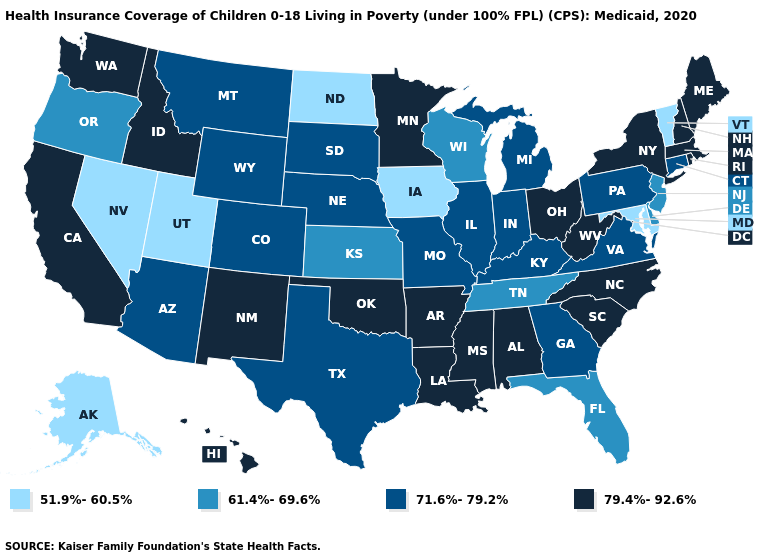What is the highest value in states that border Minnesota?
Keep it brief. 71.6%-79.2%. Does the first symbol in the legend represent the smallest category?
Write a very short answer. Yes. What is the value of Connecticut?
Give a very brief answer. 71.6%-79.2%. Which states have the lowest value in the USA?
Quick response, please. Alaska, Iowa, Maryland, Nevada, North Dakota, Utah, Vermont. What is the highest value in states that border Louisiana?
Give a very brief answer. 79.4%-92.6%. Among the states that border North Carolina , which have the highest value?
Write a very short answer. South Carolina. What is the value of Arkansas?
Short answer required. 79.4%-92.6%. Does the first symbol in the legend represent the smallest category?
Answer briefly. Yes. What is the lowest value in the USA?
Answer briefly. 51.9%-60.5%. Does Louisiana have a lower value than Ohio?
Give a very brief answer. No. What is the value of Vermont?
Give a very brief answer. 51.9%-60.5%. Does Vermont have the lowest value in the Northeast?
Keep it brief. Yes. Does the map have missing data?
Quick response, please. No. Does Utah have the lowest value in the USA?
Give a very brief answer. Yes. 